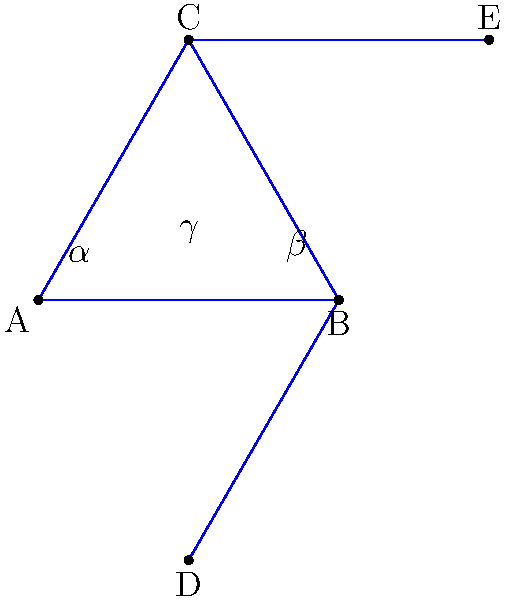In this passionate arrangement of interlocking male gender symbols, what is the measure of angle $\gamma$ in terms of angles $\alpha$ and $\beta$? Let's approach this step-by-step:

1) First, note that triangle ABC is equilateral, as it's formed by two male gender symbols. This means all its angles are 60°.

2) The line BD bisects angle ABC, creating two equal angles: $\alpha$ and $\beta$. Since the whole angle ABC is 60°, we can say:

   $\alpha + \beta = 60°$

3) The line CE is parallel to BD, as both are the stems of the male symbols. This means that the alternate angles are equal. Therefore, the angle DCE is also divided into $\alpha$ and $\beta$.

4) Now, let's focus on angle $\gamma$. It's an exterior angle of triangle BCD.

5) An exterior angle of a triangle is equal to the sum of the two non-adjacent interior angles. So:

   $\gamma = \angle CBD + \angle BDC$

6) We know that $\angle CBD = 60°$ (it's an angle of the equilateral triangle ABC).

7) $\angle BDC = \alpha + \beta$ (as we established in step 3).

8) Therefore:

   $\gamma = 60° + (\alpha + \beta)$

9) But we know from step 2 that $\alpha + \beta = 60°$, so:

   $\gamma = 60° + 60° = 120°$

Thus, regardless of the individual values of $\alpha$ and $\beta$, as long as they sum to 60°, $\gamma$ will always be 120°.
Answer: $120°$ 